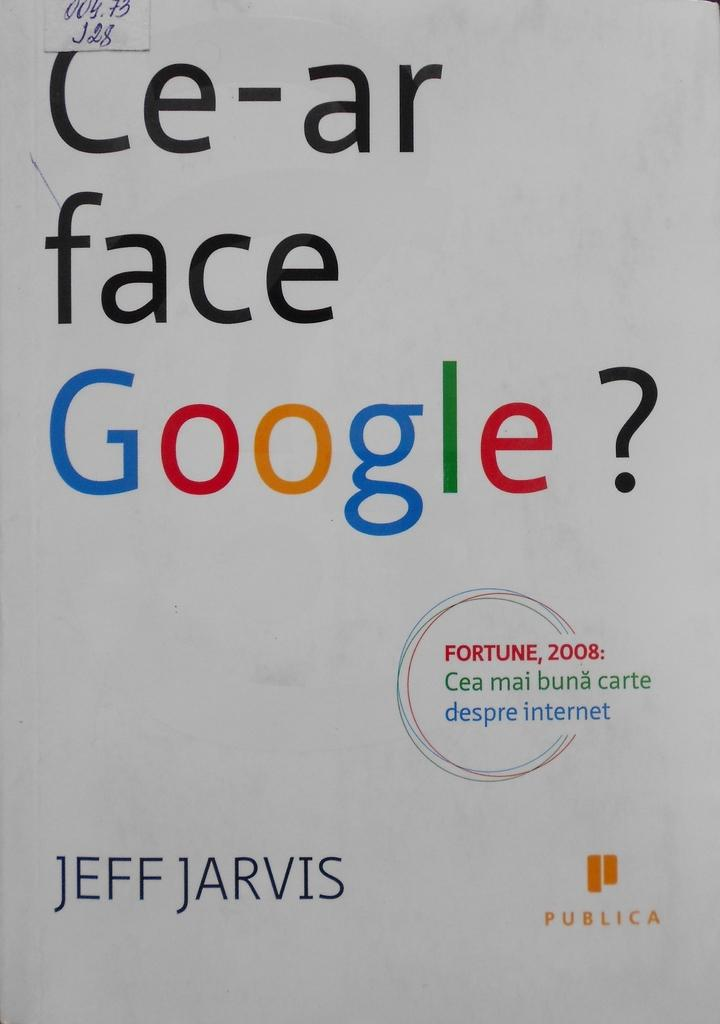<image>
Render a clear and concise summary of the photo. the word Google is on the white piece of paper 